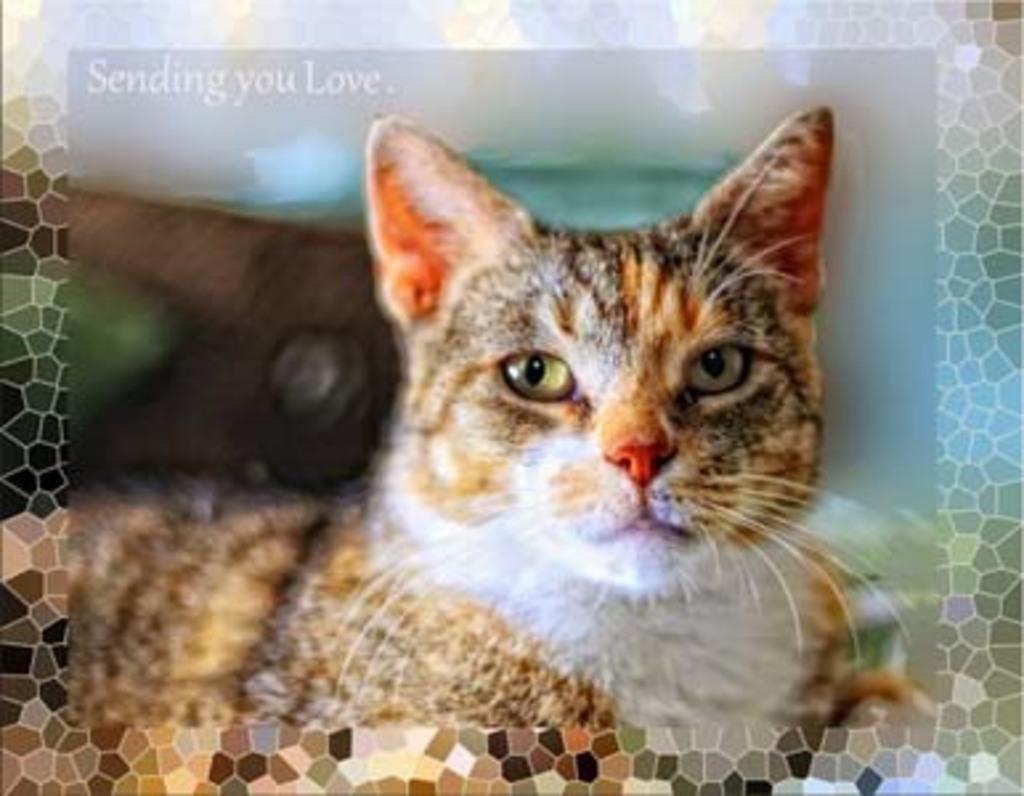Can you describe this image briefly? This is an edited image. In this image we can see a cat. We can also see some text. 